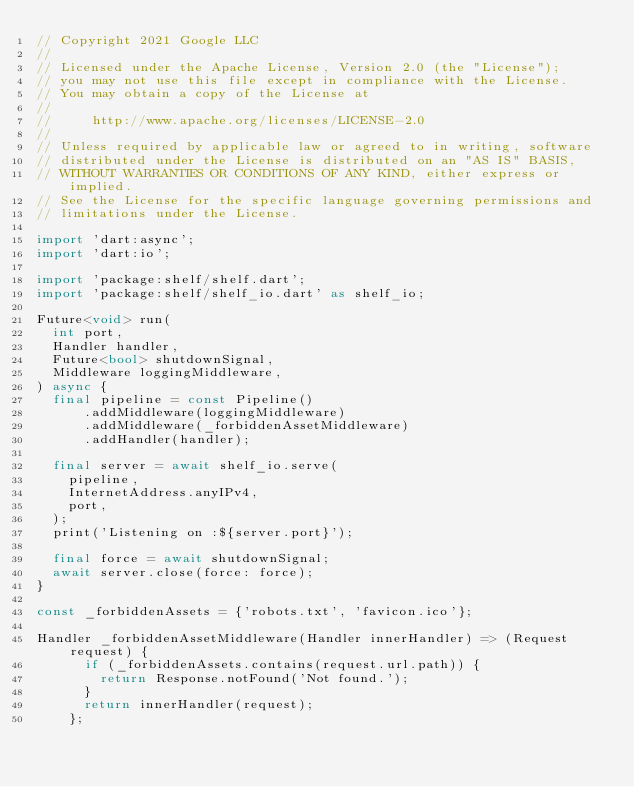Convert code to text. <code><loc_0><loc_0><loc_500><loc_500><_Dart_>// Copyright 2021 Google LLC
//
// Licensed under the Apache License, Version 2.0 (the "License");
// you may not use this file except in compliance with the License.
// You may obtain a copy of the License at
//
//     http://www.apache.org/licenses/LICENSE-2.0
//
// Unless required by applicable law or agreed to in writing, software
// distributed under the License is distributed on an "AS IS" BASIS,
// WITHOUT WARRANTIES OR CONDITIONS OF ANY KIND, either express or implied.
// See the License for the specific language governing permissions and
// limitations under the License.

import 'dart:async';
import 'dart:io';

import 'package:shelf/shelf.dart';
import 'package:shelf/shelf_io.dart' as shelf_io;

Future<void> run(
  int port,
  Handler handler,
  Future<bool> shutdownSignal,
  Middleware loggingMiddleware,
) async {
  final pipeline = const Pipeline()
      .addMiddleware(loggingMiddleware)
      .addMiddleware(_forbiddenAssetMiddleware)
      .addHandler(handler);

  final server = await shelf_io.serve(
    pipeline,
    InternetAddress.anyIPv4,
    port,
  );
  print('Listening on :${server.port}');

  final force = await shutdownSignal;
  await server.close(force: force);
}

const _forbiddenAssets = {'robots.txt', 'favicon.ico'};

Handler _forbiddenAssetMiddleware(Handler innerHandler) => (Request request) {
      if (_forbiddenAssets.contains(request.url.path)) {
        return Response.notFound('Not found.');
      }
      return innerHandler(request);
    };
</code> 